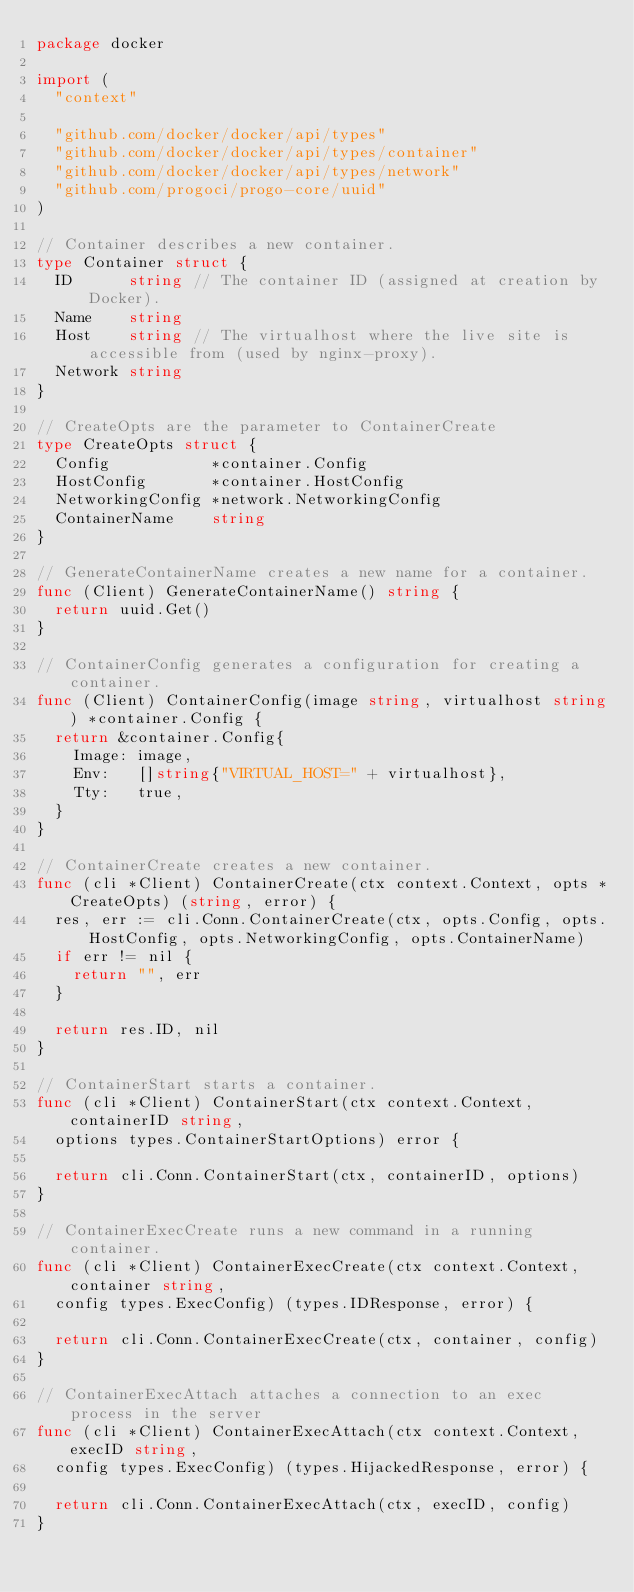Convert code to text. <code><loc_0><loc_0><loc_500><loc_500><_Go_>package docker

import (
	"context"

	"github.com/docker/docker/api/types"
	"github.com/docker/docker/api/types/container"
	"github.com/docker/docker/api/types/network"
	"github.com/progoci/progo-core/uuid"
)

// Container describes a new container.
type Container struct {
	ID      string // The container ID (assigned at creation by Docker).
	Name    string
	Host    string // The virtualhost where the live site is accessible from (used by nginx-proxy).
	Network string
}

// CreateOpts are the parameter to ContainerCreate
type CreateOpts struct {
	Config           *container.Config
	HostConfig       *container.HostConfig
	NetworkingConfig *network.NetworkingConfig
	ContainerName    string
}

// GenerateContainerName creates a new name for a container.
func (Client) GenerateContainerName() string {
	return uuid.Get()
}

// ContainerConfig generates a configuration for creating a container.
func (Client) ContainerConfig(image string, virtualhost string) *container.Config {
	return &container.Config{
		Image: image,
		Env:   []string{"VIRTUAL_HOST=" + virtualhost},
		Tty:   true,
	}
}

// ContainerCreate creates a new container.
func (cli *Client) ContainerCreate(ctx context.Context, opts *CreateOpts) (string, error) {
	res, err := cli.Conn.ContainerCreate(ctx, opts.Config, opts.HostConfig, opts.NetworkingConfig, opts.ContainerName)
	if err != nil {
		return "", err
	}

	return res.ID, nil
}

// ContainerStart starts a container.
func (cli *Client) ContainerStart(ctx context.Context, containerID string,
	options types.ContainerStartOptions) error {

	return cli.Conn.ContainerStart(ctx, containerID, options)
}

// ContainerExecCreate runs a new command in a running container.
func (cli *Client) ContainerExecCreate(ctx context.Context, container string,
	config types.ExecConfig) (types.IDResponse, error) {

	return cli.Conn.ContainerExecCreate(ctx, container, config)
}

// ContainerExecAttach attaches a connection to an exec process in the server
func (cli *Client) ContainerExecAttach(ctx context.Context, execID string,
	config types.ExecConfig) (types.HijackedResponse, error) {

	return cli.Conn.ContainerExecAttach(ctx, execID, config)
}
</code> 